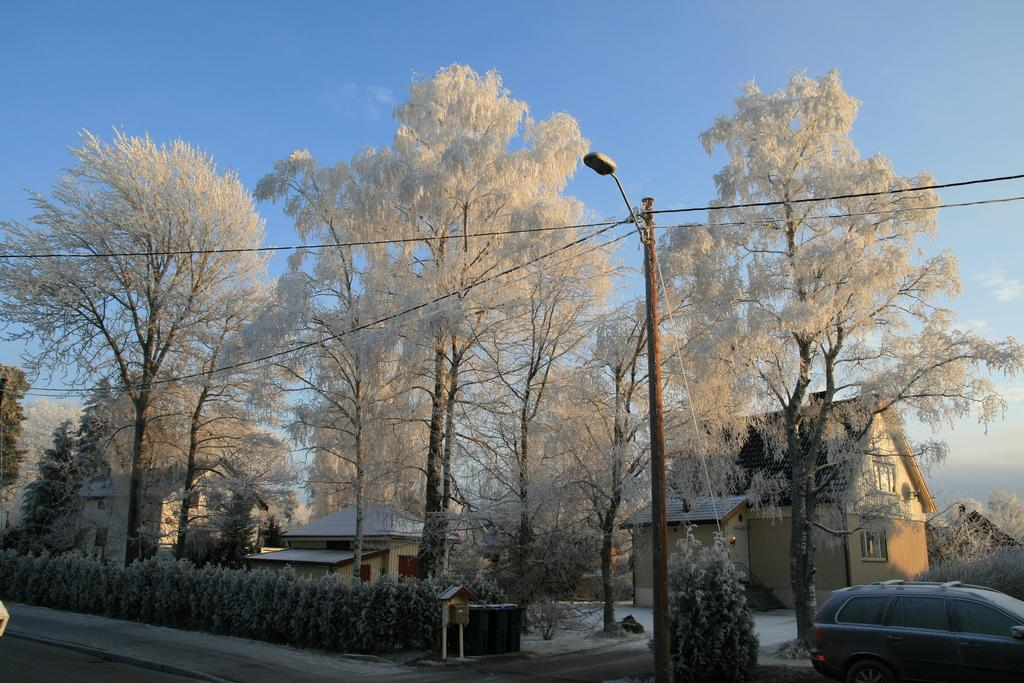What is the main subject of the image? There is a car on the road in the image. What can be seen in the background of the image? There are dried trees and a light pole in the background of the image. What is the color of the sky in the image? The sky is blue in color in the image. What type of treatment is being administered to the baby in the image? There is no baby present in the image, so no treatment can be observed. 